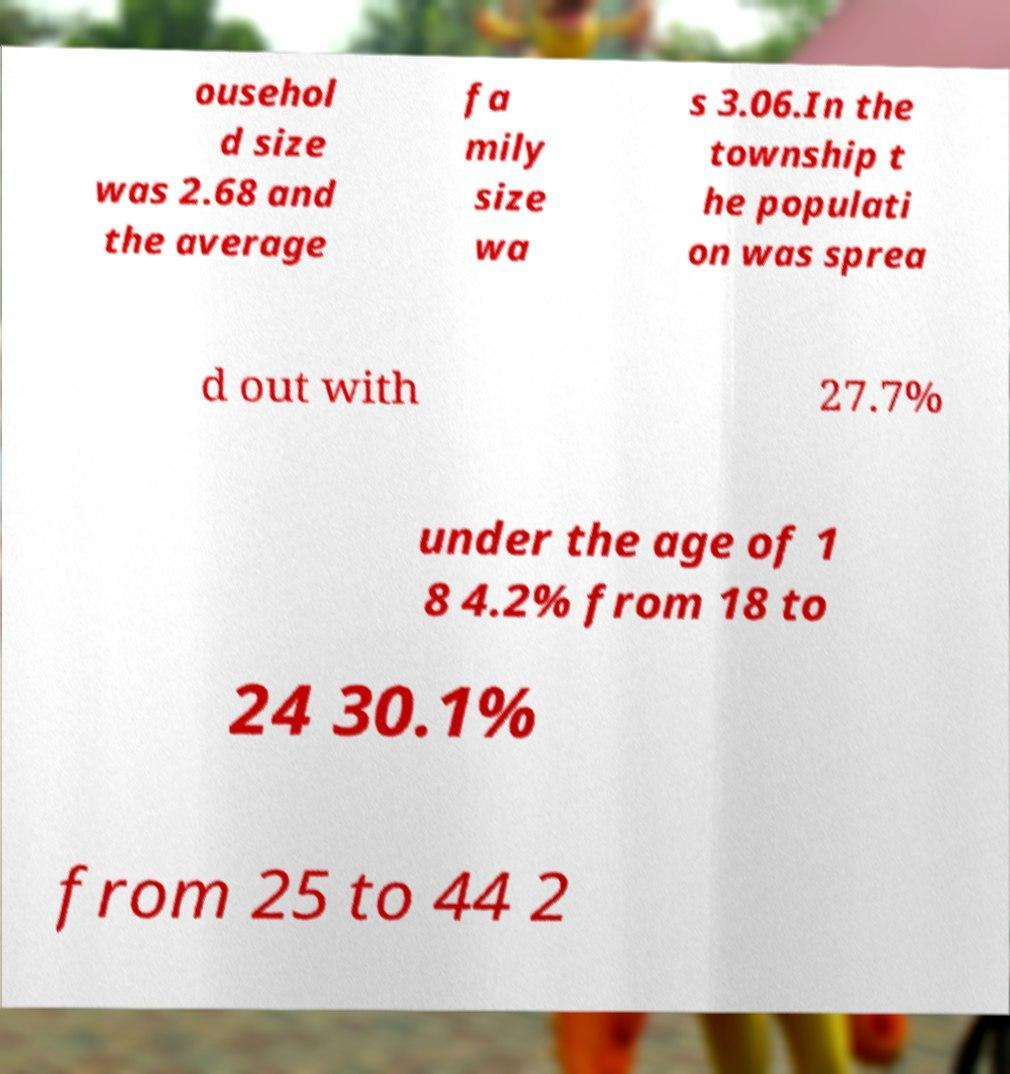For documentation purposes, I need the text within this image transcribed. Could you provide that? ousehol d size was 2.68 and the average fa mily size wa s 3.06.In the township t he populati on was sprea d out with 27.7% under the age of 1 8 4.2% from 18 to 24 30.1% from 25 to 44 2 